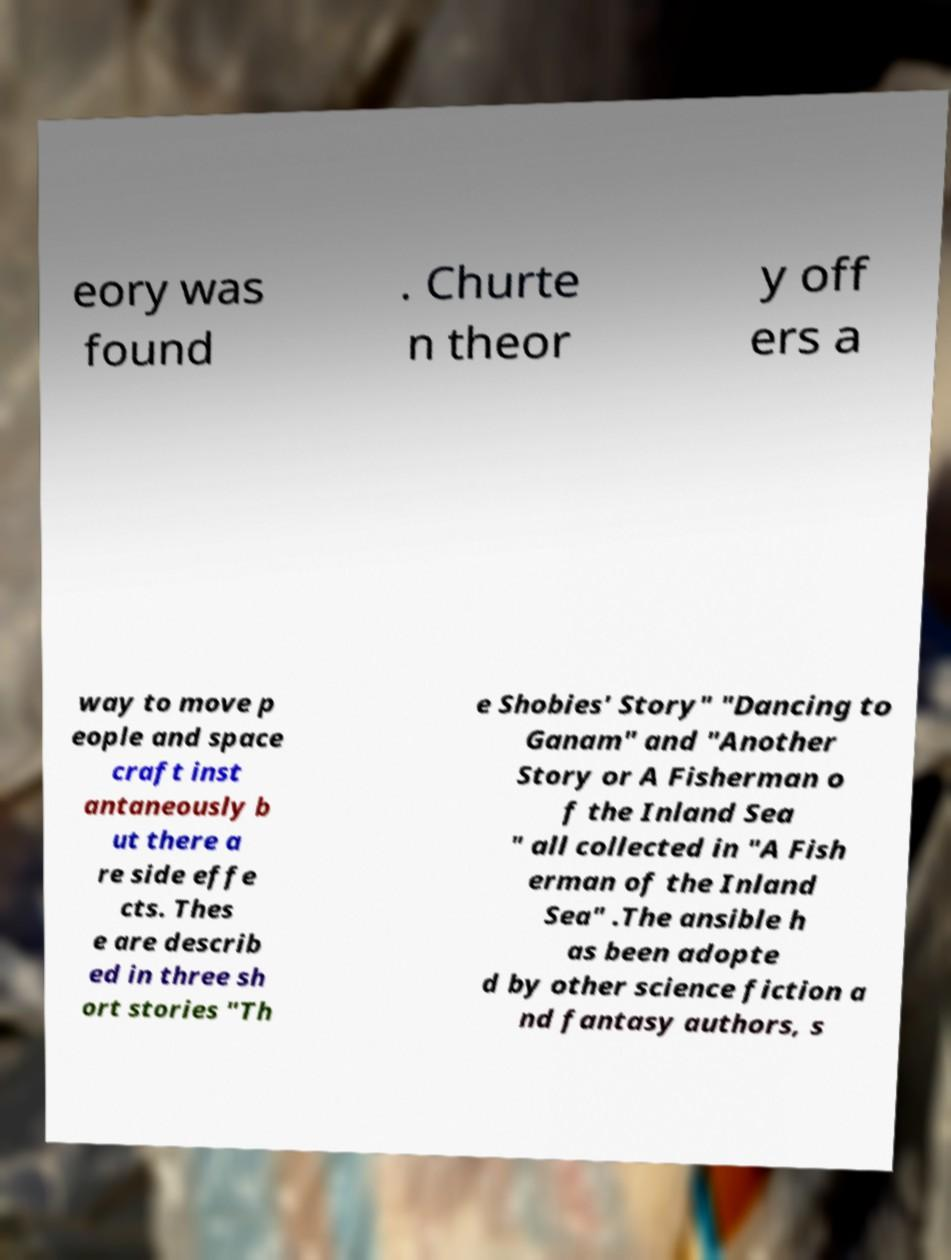Could you assist in decoding the text presented in this image and type it out clearly? eory was found . Churte n theor y off ers a way to move p eople and space craft inst antaneously b ut there a re side effe cts. Thes e are describ ed in three sh ort stories "Th e Shobies' Story" "Dancing to Ganam" and "Another Story or A Fisherman o f the Inland Sea " all collected in "A Fish erman of the Inland Sea" .The ansible h as been adopte d by other science fiction a nd fantasy authors, s 